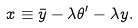Convert formula to latex. <formula><loc_0><loc_0><loc_500><loc_500>x \equiv \bar { y } - \lambda \theta ^ { \prime } - \lambda y .</formula> 